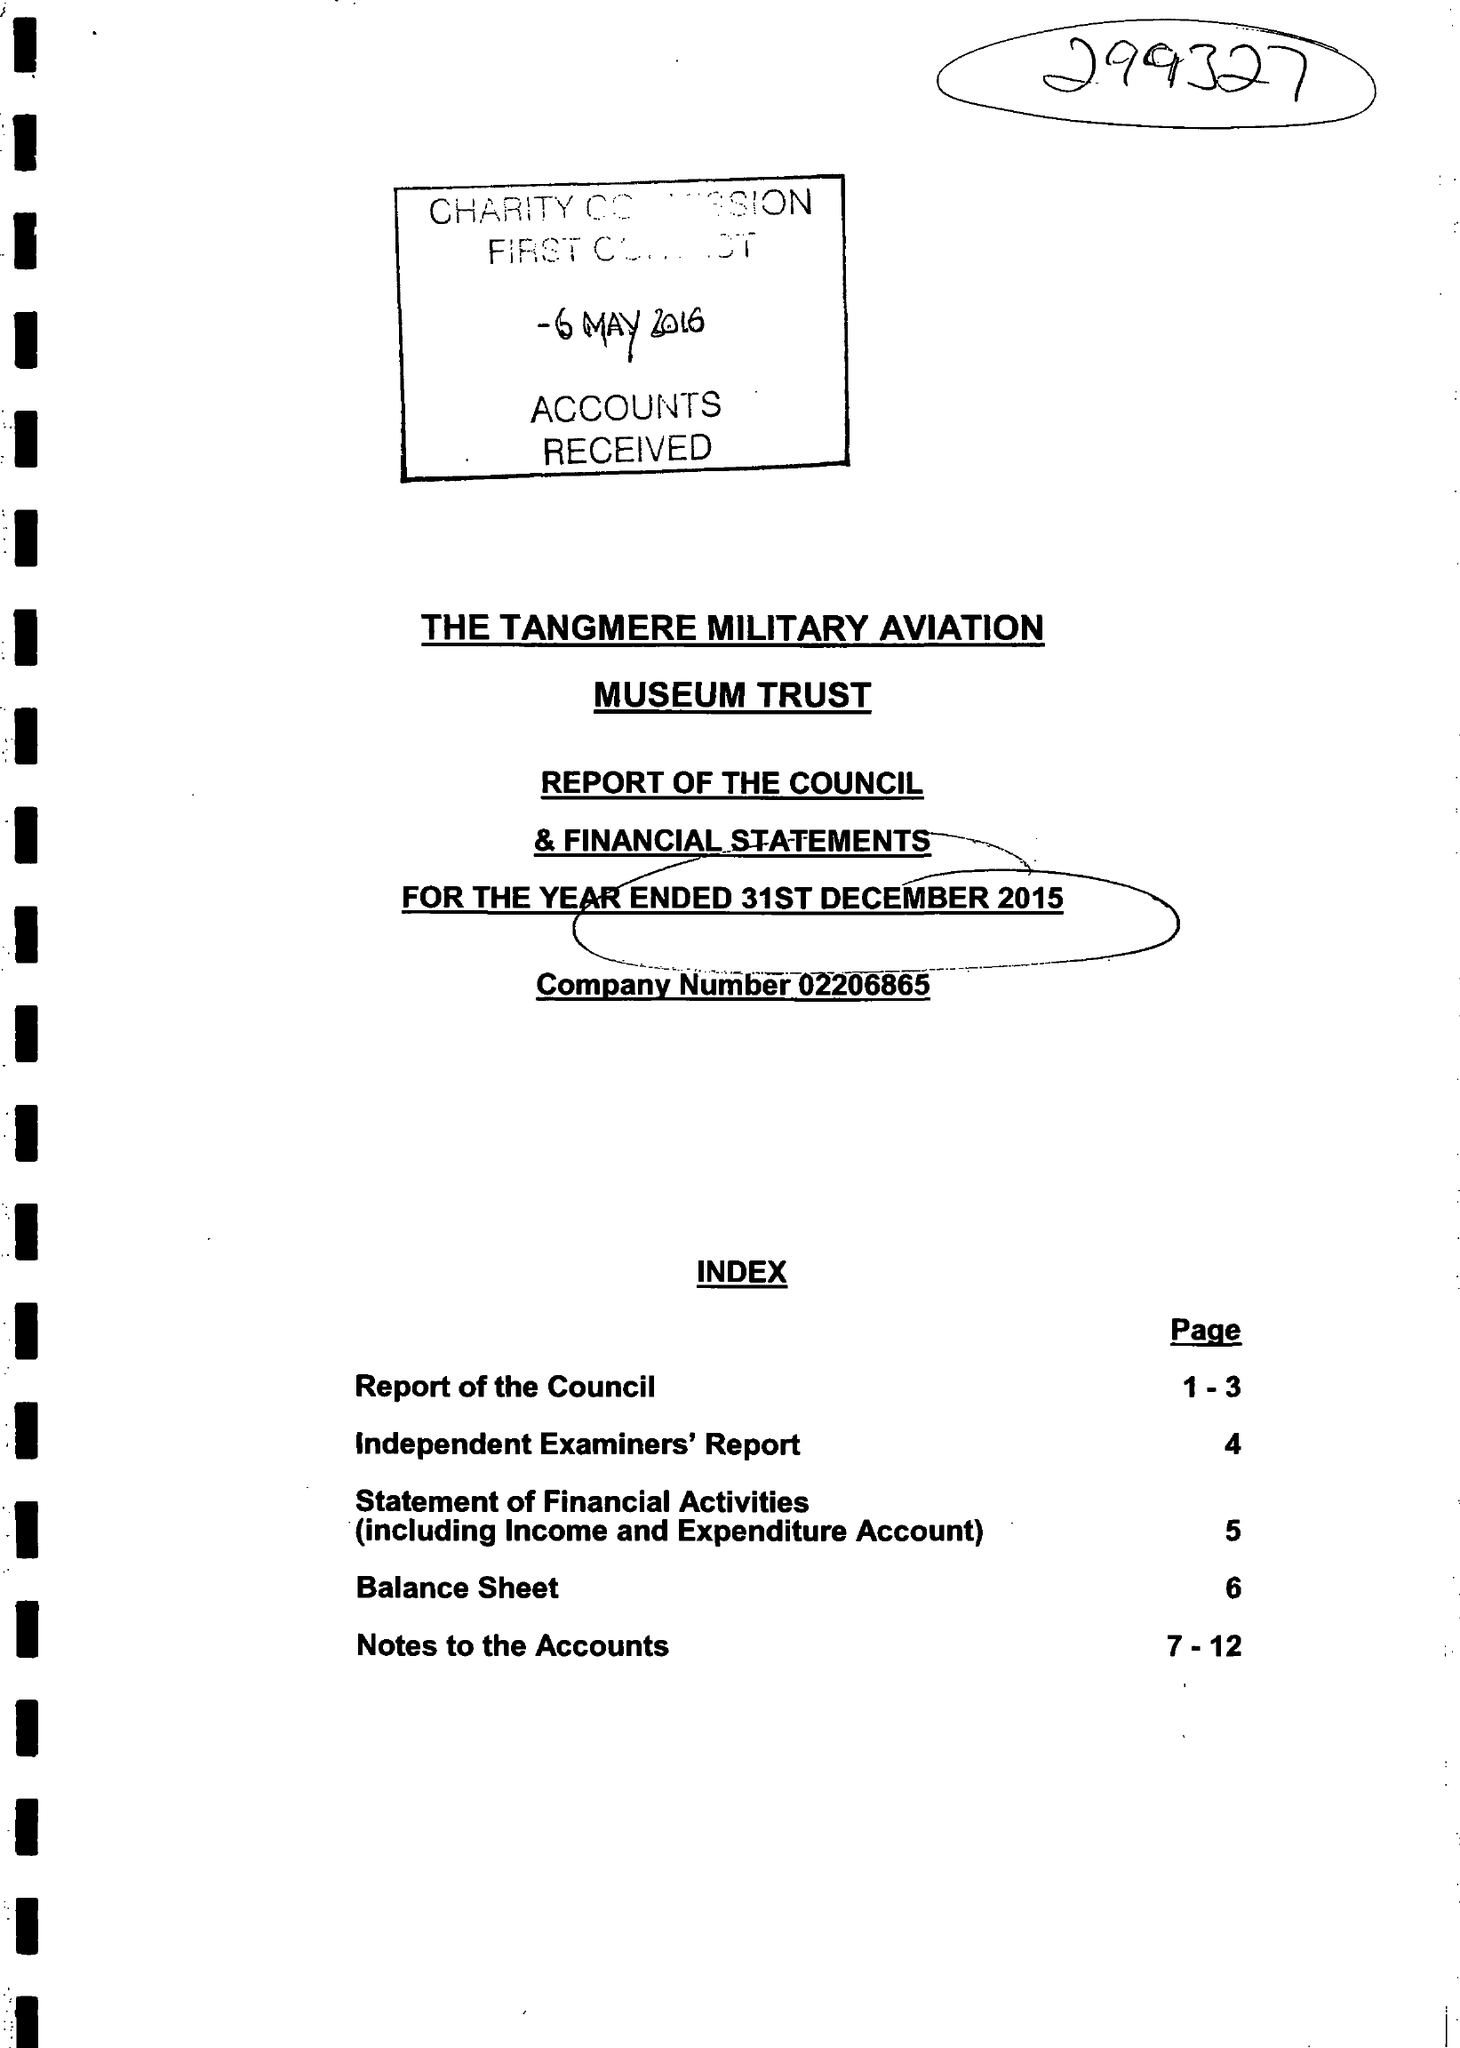What is the value for the address__street_line?
Answer the question using a single word or phrase. None 